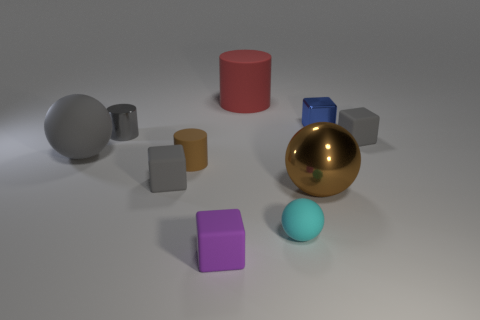Subtract all matte cubes. How many cubes are left? 1 Subtract all gray blocks. How many blocks are left? 2 Subtract 2 balls. How many balls are left? 1 Subtract all blocks. How many objects are left? 6 Subtract all purple spheres. How many cyan cylinders are left? 0 Add 9 gray cylinders. How many gray cylinders are left? 10 Add 7 small blue metallic objects. How many small blue metallic objects exist? 8 Subtract 0 red balls. How many objects are left? 10 Subtract all yellow cylinders. Subtract all cyan cubes. How many cylinders are left? 3 Subtract all big matte things. Subtract all large rubber objects. How many objects are left? 6 